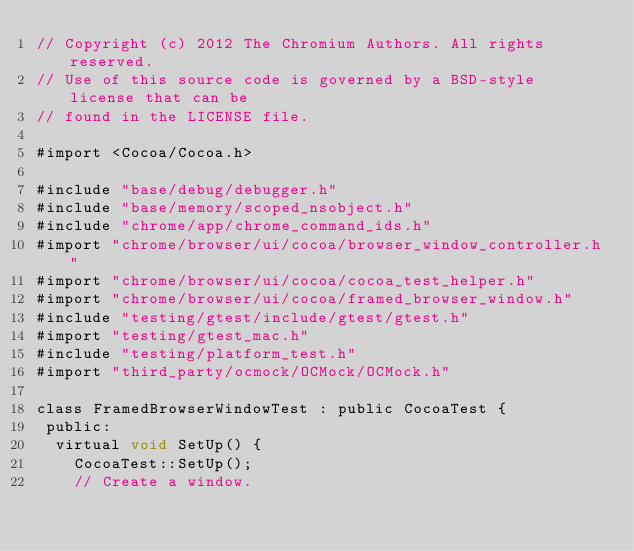Convert code to text. <code><loc_0><loc_0><loc_500><loc_500><_ObjectiveC_>// Copyright (c) 2012 The Chromium Authors. All rights reserved.
// Use of this source code is governed by a BSD-style license that can be
// found in the LICENSE file.

#import <Cocoa/Cocoa.h>

#include "base/debug/debugger.h"
#include "base/memory/scoped_nsobject.h"
#include "chrome/app/chrome_command_ids.h"
#import "chrome/browser/ui/cocoa/browser_window_controller.h"
#import "chrome/browser/ui/cocoa/cocoa_test_helper.h"
#import "chrome/browser/ui/cocoa/framed_browser_window.h"
#include "testing/gtest/include/gtest/gtest.h"
#import "testing/gtest_mac.h"
#include "testing/platform_test.h"
#import "third_party/ocmock/OCMock/OCMock.h"

class FramedBrowserWindowTest : public CocoaTest {
 public:
  virtual void SetUp() {
    CocoaTest::SetUp();
    // Create a window.</code> 